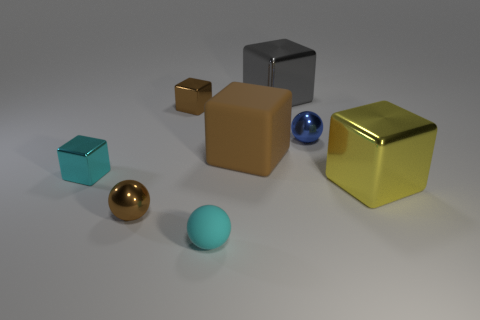Subtract all gray metal cubes. How many cubes are left? 4 Add 1 metallic cubes. How many objects exist? 9 Subtract all cyan balls. How many balls are left? 2 Subtract all blocks. How many objects are left? 3 Subtract all gray cylinders. How many brown spheres are left? 1 Subtract all cyan objects. Subtract all brown metal cubes. How many objects are left? 5 Add 6 brown matte blocks. How many brown matte blocks are left? 7 Add 3 tiny brown balls. How many tiny brown balls exist? 4 Subtract 0 purple balls. How many objects are left? 8 Subtract 2 blocks. How many blocks are left? 3 